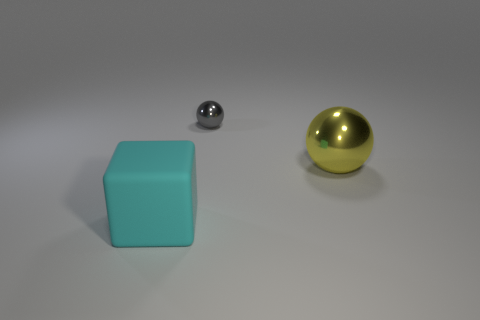Add 1 balls. How many objects exist? 4 Subtract all blocks. How many objects are left? 2 Add 3 large yellow balls. How many large yellow balls exist? 4 Subtract 0 red cylinders. How many objects are left? 3 Subtract all red shiny cylinders. Subtract all big matte blocks. How many objects are left? 2 Add 1 large yellow shiny things. How many large yellow shiny things are left? 2 